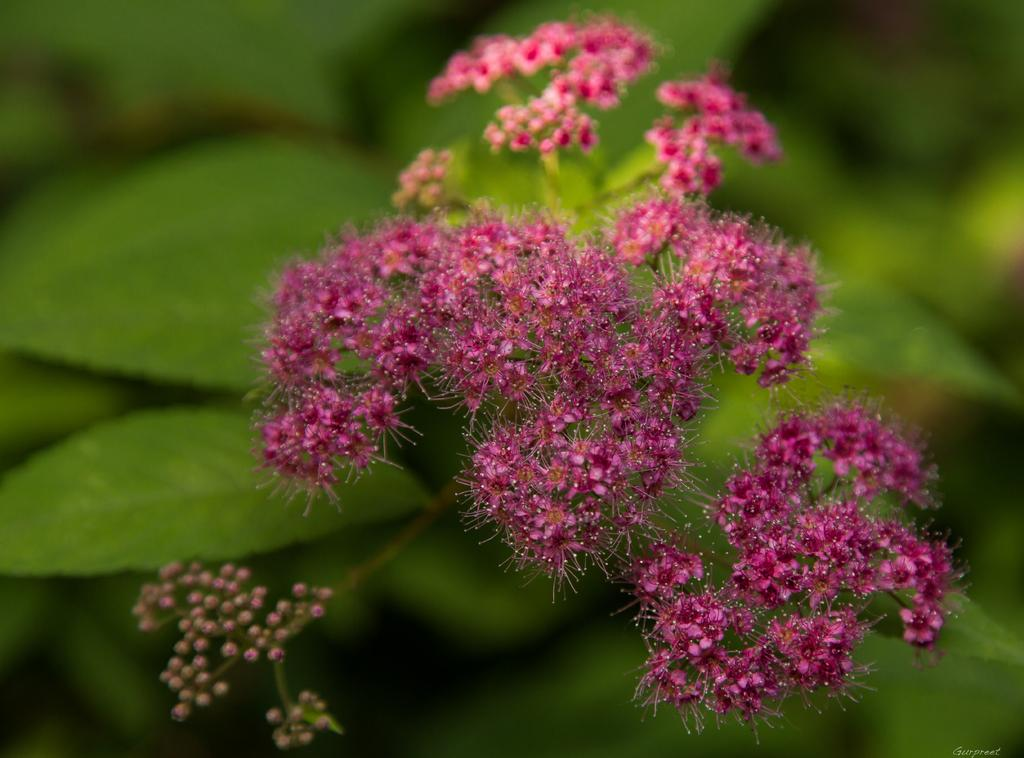What color are the flowers in the image? The flowers in the image are pink. What stage of growth are some of the flowers in? There are buds in the image, indicating that some flowers are not yet fully bloomed. What color are the leaves in the background of the image? The leaves in the background of the image are green. How is the background of the image depicted? The background is blurred. What type of coat is the dog wearing in the image? There are no dogs or coats present in the image; it features pink flowers, buds, green leaves, and a blurred background. 